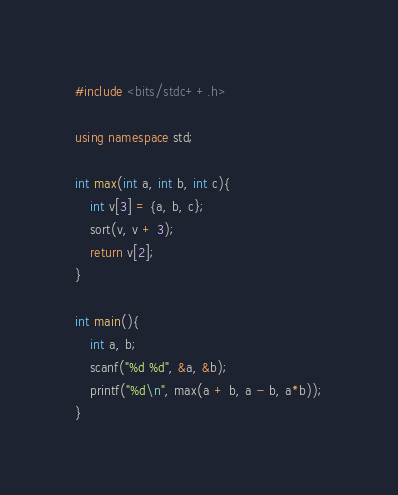Convert code to text. <code><loc_0><loc_0><loc_500><loc_500><_C++_>#include <bits/stdc++.h>

using namespace std;

int max(int a, int b, int c){
	int v[3] = {a, b, c};
	sort(v, v + 3);
	return v[2];
}

int main(){
	int a, b;
	scanf("%d %d", &a, &b);
	printf("%d\n", max(a + b, a - b, a*b));
}</code> 